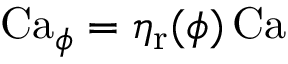<formula> <loc_0><loc_0><loc_500><loc_500>C a _ { \phi } = \eta _ { r } ( \phi ) \, C a</formula> 